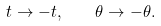<formula> <loc_0><loc_0><loc_500><loc_500>t \to - t , \quad \theta \to - \theta .</formula> 